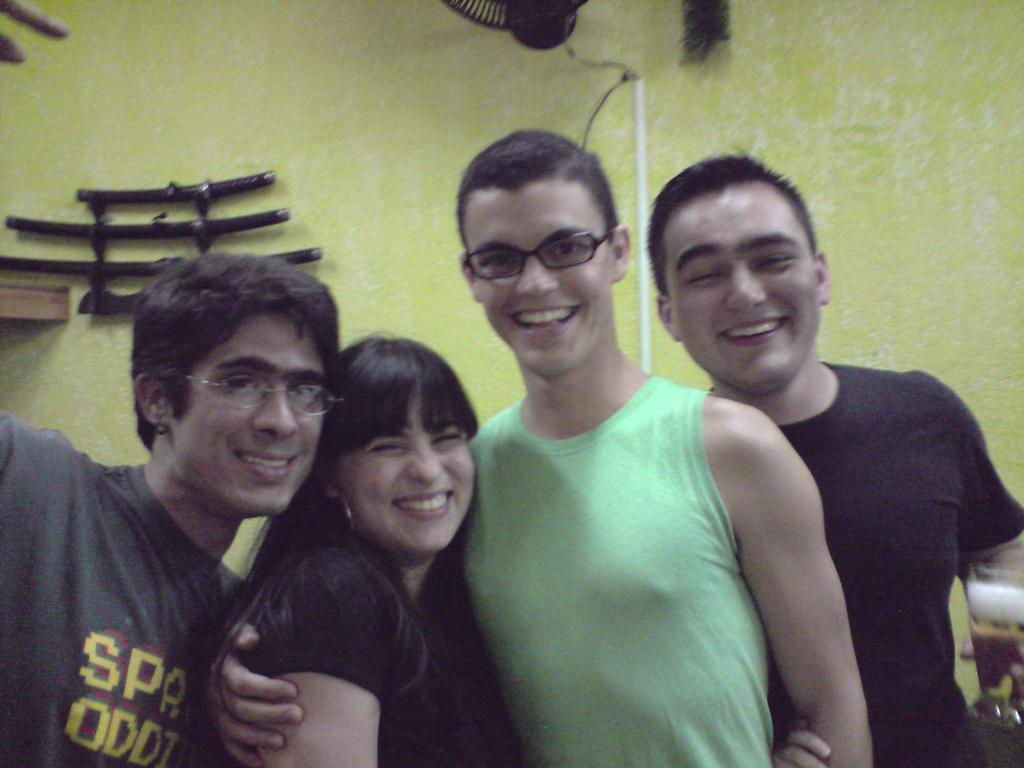How many people are in the image? There are three men and one woman in the image, making a total of four individuals. What are the people in the image doing? The individuals are standing together and smiling. What is the woman wearing in the image? The woman is wearing a black dress. What can be seen in the background of the image? There is a wall visible in the background, and objects are placed on the wall. What is the tendency of the roof in the image? There is no roof present in the image; it only features a wall in the background. What type of room is depicted in the image? The image does not show a room; it only shows a group of people standing together with a wall in the background. 